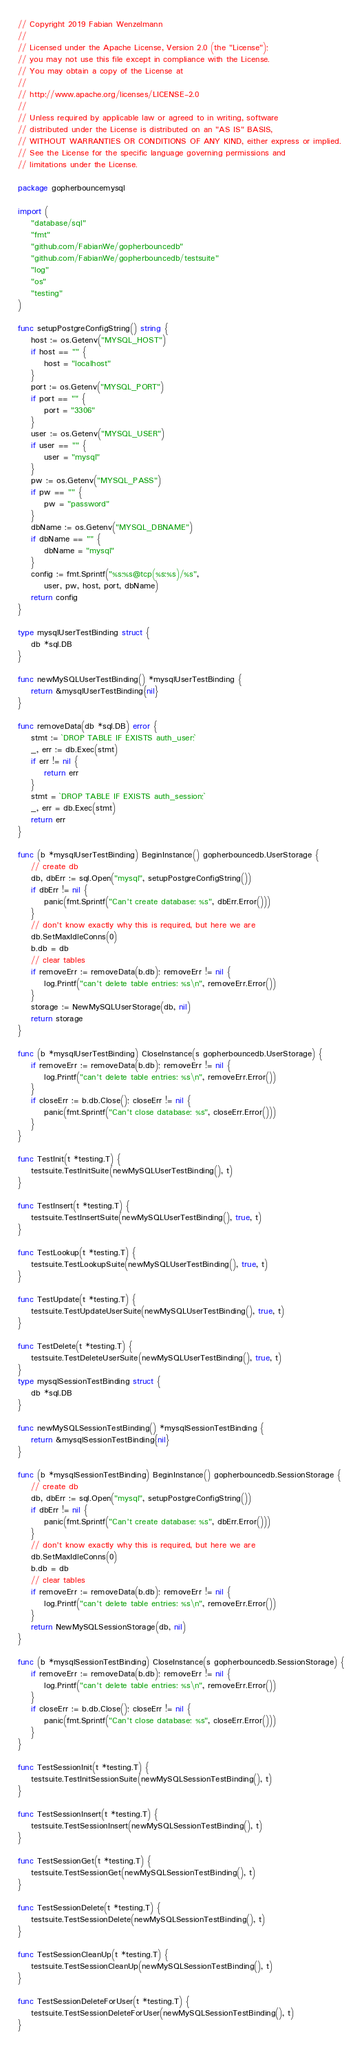Convert code to text. <code><loc_0><loc_0><loc_500><loc_500><_Go_>// Copyright 2019 Fabian Wenzelmann
//
// Licensed under the Apache License, Version 2.0 (the "License");
// you may not use this file except in compliance with the License.
// You may obtain a copy of the License at
//
// http://www.apache.org/licenses/LICENSE-2.0
//
// Unless required by applicable law or agreed to in writing, software
// distributed under the License is distributed on an "AS IS" BASIS,
// WITHOUT WARRANTIES OR CONDITIONS OF ANY KIND, either express or implied.
// See the License for the specific language governing permissions and
// limitations under the License.

package gopherbouncemysql

import (
	"database/sql"
	"fmt"
	"github.com/FabianWe/gopherbouncedb"
	"github.com/FabianWe/gopherbouncedb/testsuite"
	"log"
	"os"
	"testing"
)

func setupPostgreConfigString() string {
	host := os.Getenv("MYSQL_HOST")
	if host == "" {
		host = "localhost"
	}
	port := os.Getenv("MYSQL_PORT")
	if port == "" {
		port = "3306"
	}
	user := os.Getenv("MYSQL_USER")
	if user == "" {
		user = "mysql"
	}
	pw := os.Getenv("MYSQL_PASS")
	if pw == "" {
		pw = "password"
	}
	dbName := os.Getenv("MYSQL_DBNAME")
	if dbName == "" {
		dbName = "mysql"
	}
	config := fmt.Sprintf("%s:%s@tcp(%s:%s)/%s",
		user, pw, host, port, dbName)
	return config
}

type mysqlUserTestBinding struct {
	db *sql.DB
}

func newMySQLUserTestBinding() *mysqlUserTestBinding {
	return &mysqlUserTestBinding{nil}
}

func removeData(db *sql.DB) error {
	stmt := `DROP TABLE IF EXISTS auth_user;`
	_, err := db.Exec(stmt)
	if err != nil {
		return err
	}
	stmt = `DROP TABLE IF EXISTS auth_session;`
	_, err = db.Exec(stmt)
	return err
}

func (b *mysqlUserTestBinding) BeginInstance() gopherbouncedb.UserStorage {
	// create db
	db, dbErr := sql.Open("mysql", setupPostgreConfigString())
	if dbErr != nil {
		panic(fmt.Sprintf("Can't create database: %s", dbErr.Error()))
	}
	// don't know exactly why this is required, but here we are
	db.SetMaxIdleConns(0)
	b.db = db
	// clear tables
	if removeErr := removeData(b.db); removeErr != nil {
		log.Printf("can't delete table entries: %s\n", removeErr.Error())
	}
	storage := NewMySQLUserStorage(db, nil)
	return storage
}

func (b *mysqlUserTestBinding) CloseInstance(s gopherbouncedb.UserStorage) {
	if removeErr := removeData(b.db); removeErr != nil {
		log.Printf("can't delete table entries: %s\n", removeErr.Error())
	}
	if closeErr := b.db.Close(); closeErr != nil {
		panic(fmt.Sprintf("Can't close database: %s", closeErr.Error()))
	}
}

func TestInit(t *testing.T) {
	testsuite.TestInitSuite(newMySQLUserTestBinding(), t)
}

func TestInsert(t *testing.T) {
	testsuite.TestInsertSuite(newMySQLUserTestBinding(), true, t)
}

func TestLookup(t *testing.T) {
	testsuite.TestLookupSuite(newMySQLUserTestBinding(), true, t)
}

func TestUpdate(t *testing.T) {
	testsuite.TestUpdateUserSuite(newMySQLUserTestBinding(), true, t)
}

func TestDelete(t *testing.T) {
	testsuite.TestDeleteUserSuite(newMySQLUserTestBinding(), true, t)
}
type mysqlSessionTestBinding struct {
	db *sql.DB
}

func newMySQLSessionTestBinding() *mysqlSessionTestBinding {
	return &mysqlSessionTestBinding{nil}
}

func (b *mysqlSessionTestBinding) BeginInstance() gopherbouncedb.SessionStorage {
	// create db
	db, dbErr := sql.Open("mysql", setupPostgreConfigString())
	if dbErr != nil {
		panic(fmt.Sprintf("Can't create database: %s", dbErr.Error()))
	}
	// don't know exactly why this is required, but here we are
	db.SetMaxIdleConns(0)
	b.db = db
	// clear tables
	if removeErr := removeData(b.db); removeErr != nil {
		log.Printf("can't delete table entries: %s\n", removeErr.Error())
	}
	return NewMySQLSessionStorage(db, nil)
}

func (b *mysqlSessionTestBinding) CloseInstance(s gopherbouncedb.SessionStorage) {
	if removeErr := removeData(b.db); removeErr != nil {
		log.Printf("can't delete table entries: %s\n", removeErr.Error())
	}
	if closeErr := b.db.Close(); closeErr != nil {
		panic(fmt.Sprintf("Can't close database: %s", closeErr.Error()))
	}
}

func TestSessionInit(t *testing.T) {
	testsuite.TestInitSessionSuite(newMySQLSessionTestBinding(), t)
}

func TestSessionInsert(t *testing.T) {
	testsuite.TestSessionInsert(newMySQLSessionTestBinding(), t)
}

func TestSessionGet(t *testing.T) {
	testsuite.TestSessionGet(newMySQLSessionTestBinding(), t)
}

func TestSessionDelete(t *testing.T) {
	testsuite.TestSessionDelete(newMySQLSessionTestBinding(), t)
}

func TestSessionCleanUp(t *testing.T) {
	testsuite.TestSessionCleanUp(newMySQLSessionTestBinding(), t)
}

func TestSessionDeleteForUser(t *testing.T) {
	testsuite.TestSessionDeleteForUser(newMySQLSessionTestBinding(), t)
}
</code> 